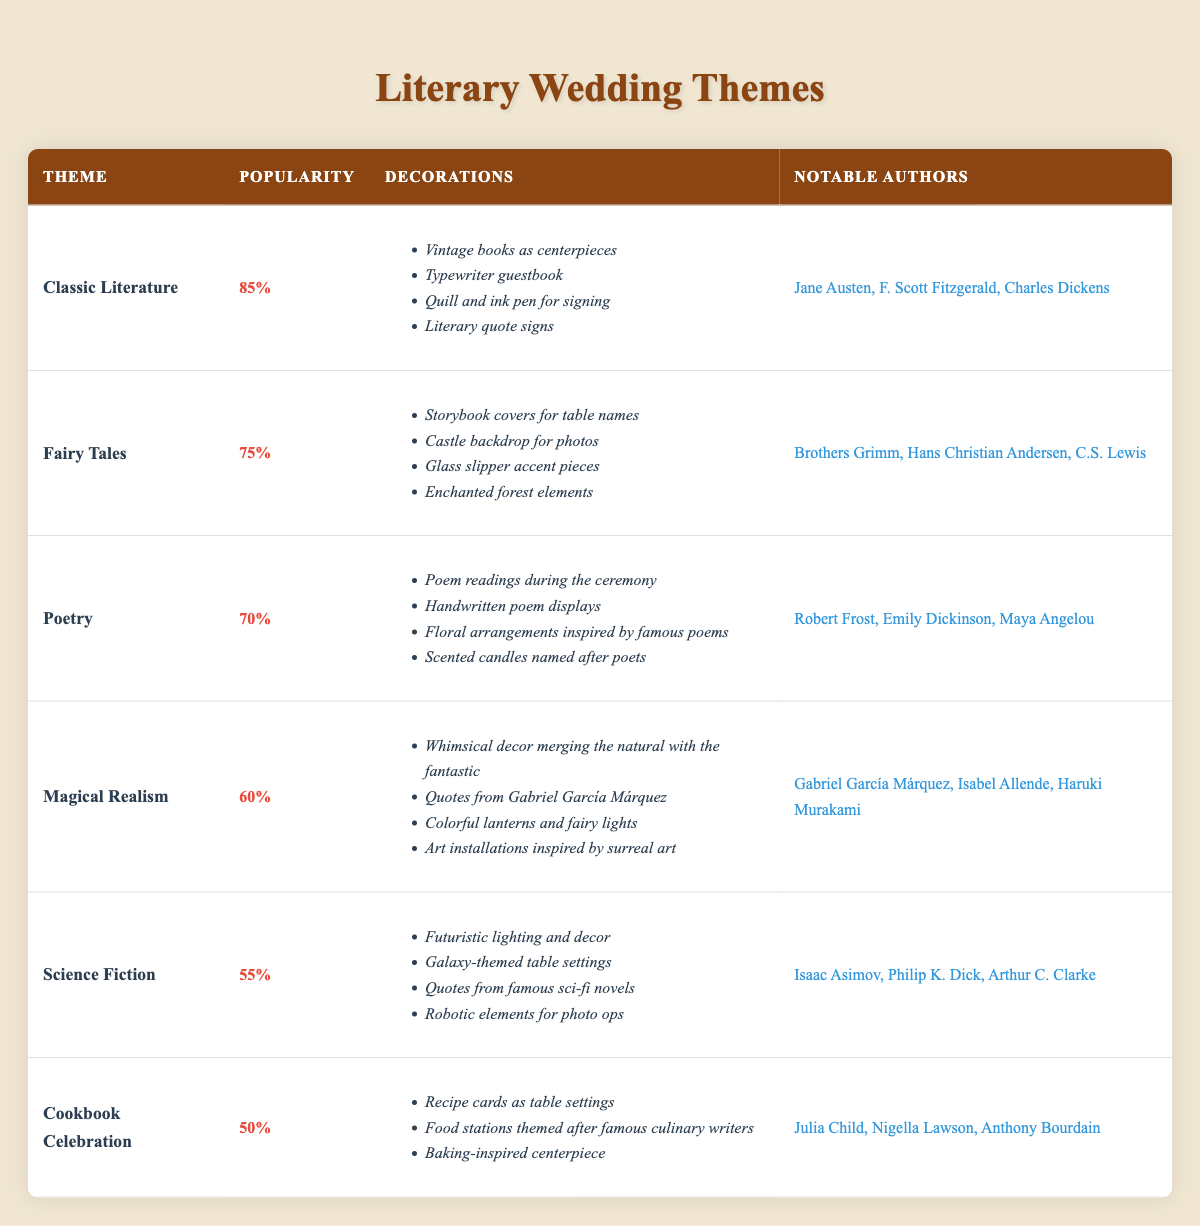What is the most popular wedding theme based on the table? The theme with the highest popularity score is "Classic Literature," which has a score of 85.
Answer: Classic Literature Which wedding theme is associated with authors such as Robert Frost and Emily Dickinson? "Poetry" is the theme connected to these authors in the table.
Answer: Poetry How many themes have a popularity score of 70 or more? The themes with scores of 70 or more are "Classic Literature," "Fairy Tales," and "Poetry," totaling three themes.
Answer: 3 What is the least popular wedding theme according to the table? "Cookbook Celebration" has the lowest popularity score, which is 50.
Answer: Cookbook Celebration If we sum the popularity scores of all themes, what total do we get? The total is calculated as follows: 85 + 75 + 70 + 60 + 55 + 50 = 395.
Answer: 395 Is "Magical Realism" more popular than "Science Fiction"? Yes, "Magical Realism" has a popularity score of 60, while "Science Fiction" has a score of 55, making it more popular.
Answer: Yes What is the difference between the popularity scores of "Fairy Tales" and "Cookbook Celebration"? The difference is calculated as 75 (Fairy Tales) - 50 (Cookbook Celebration) = 25.
Answer: 25 Which theme has decorations involving whimsical decor and quotes from Gabriel García Márquez? These decorations belong to "Magical Realism" as per the data in the table.
Answer: Magical Realism Does the "Science Fiction" theme include any author names from the list? Yes, it includes authors like Isaac Asimov and Philip K. Dick.
Answer: Yes What are the notable authors associated with the "Classic Literature" theme? The table lists Jane Austen, F. Scott Fitzgerald, and Charles Dickens as notable authors for this theme.
Answer: Jane Austen, F. Scott Fitzgerald, Charles Dickens 